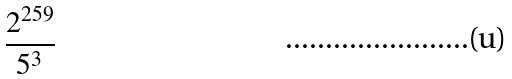Convert formula to latex. <formula><loc_0><loc_0><loc_500><loc_500>\frac { 2 ^ { 2 5 9 } } { 5 ^ { 3 } }</formula> 